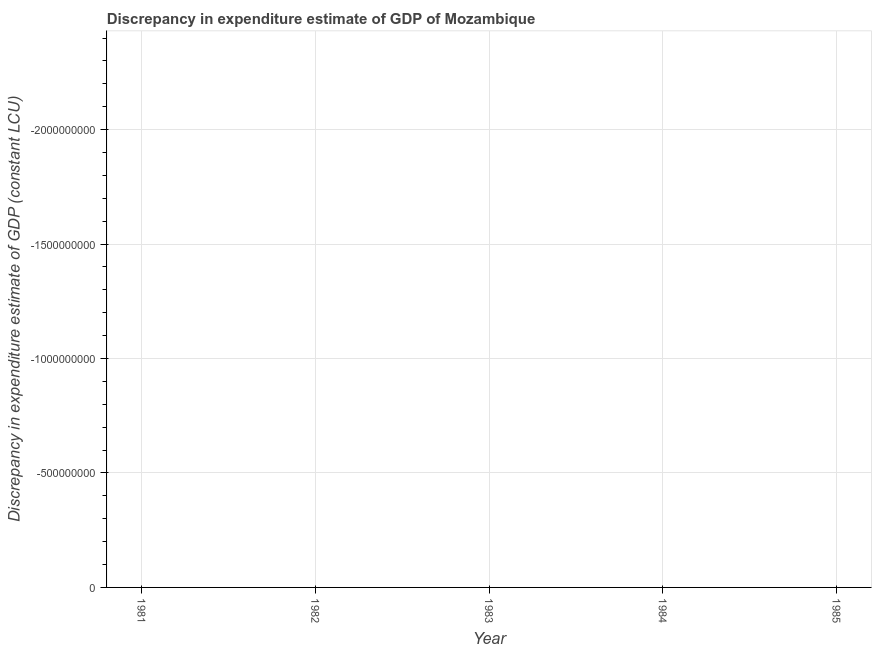What is the discrepancy in expenditure estimate of gdp in 1985?
Provide a succinct answer. 0. What is the sum of the discrepancy in expenditure estimate of gdp?
Your answer should be compact. 0. What is the average discrepancy in expenditure estimate of gdp per year?
Ensure brevity in your answer.  0. In how many years, is the discrepancy in expenditure estimate of gdp greater than the average discrepancy in expenditure estimate of gdp taken over all years?
Offer a terse response. 0. How many lines are there?
Your response must be concise. 0. How many years are there in the graph?
Offer a terse response. 5. Does the graph contain any zero values?
Keep it short and to the point. Yes. What is the title of the graph?
Your answer should be compact. Discrepancy in expenditure estimate of GDP of Mozambique. What is the label or title of the Y-axis?
Offer a terse response. Discrepancy in expenditure estimate of GDP (constant LCU). What is the Discrepancy in expenditure estimate of GDP (constant LCU) of 1982?
Your answer should be compact. 0. What is the Discrepancy in expenditure estimate of GDP (constant LCU) in 1984?
Offer a very short reply. 0. What is the Discrepancy in expenditure estimate of GDP (constant LCU) of 1985?
Your answer should be compact. 0. 